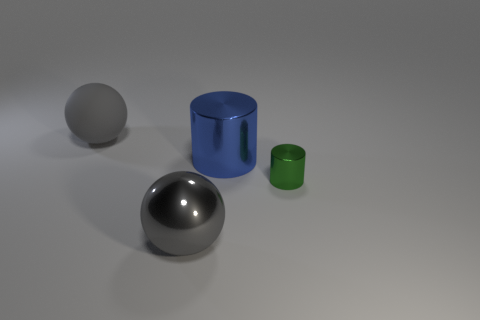What number of big gray shiny objects are the same shape as the gray matte thing?
Keep it short and to the point. 1. Is there another big metallic ball that has the same color as the metal ball?
Your answer should be compact. No. How many objects are gray balls that are to the left of the big gray shiny sphere or objects behind the big blue cylinder?
Offer a terse response. 1. There is a large gray ball behind the small metallic object; is there a green thing behind it?
Ensure brevity in your answer.  No. What is the shape of the blue metallic object that is the same size as the gray rubber sphere?
Your response must be concise. Cylinder. How many objects are shiny things in front of the tiny thing or purple cylinders?
Ensure brevity in your answer.  1. What number of other things are made of the same material as the big cylinder?
Your response must be concise. 2. What shape is the metallic thing that is the same color as the matte sphere?
Make the answer very short. Sphere. There is a gray object in front of the gray matte thing; what size is it?
Ensure brevity in your answer.  Large. The green thing that is made of the same material as the blue thing is what shape?
Your response must be concise. Cylinder. 